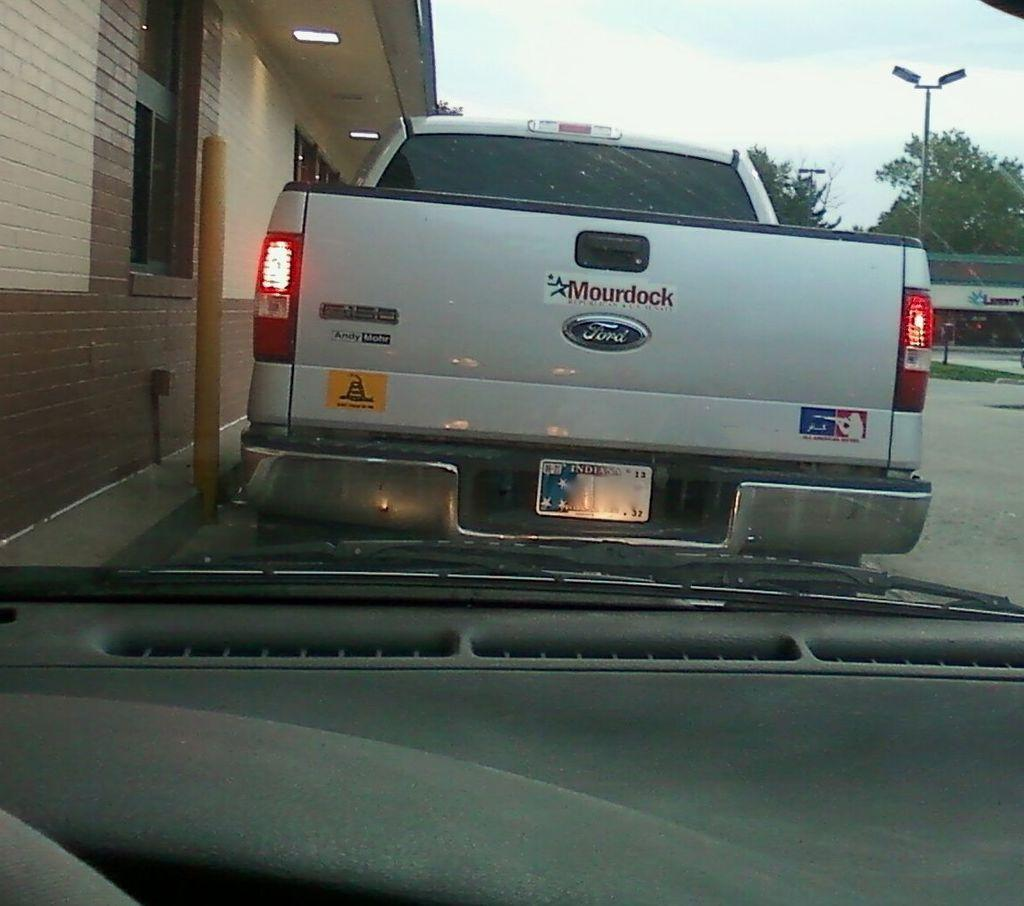<image>
Give a short and clear explanation of the subsequent image. the word mourdock that is on the back of a truck 